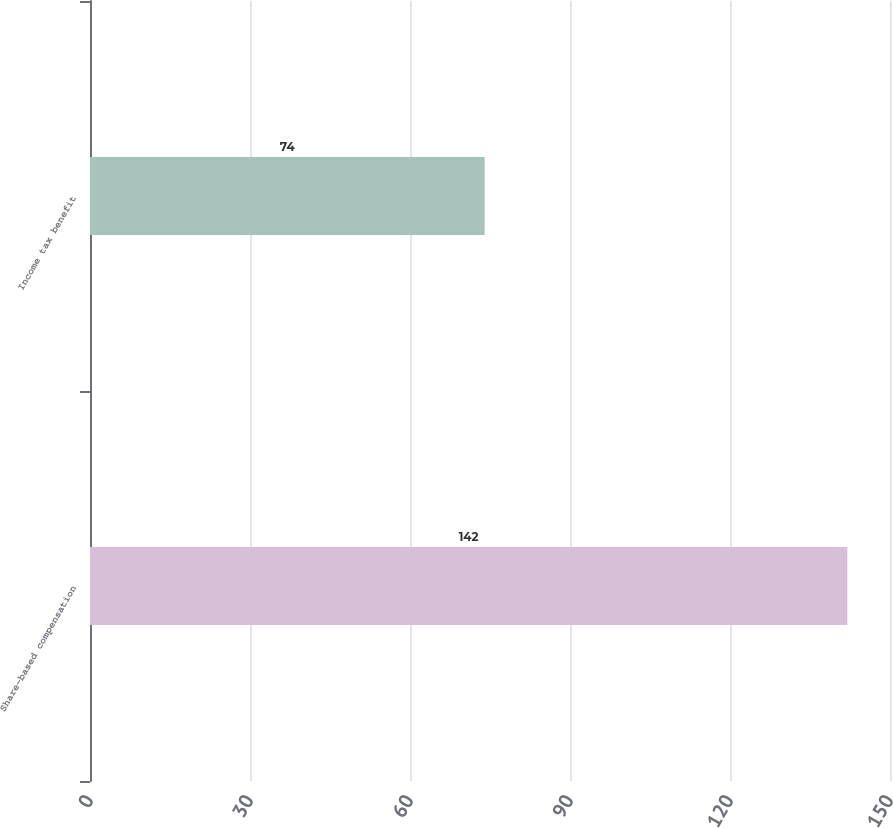Convert chart. <chart><loc_0><loc_0><loc_500><loc_500><bar_chart><fcel>Share-based compensation<fcel>Income tax benefit<nl><fcel>142<fcel>74<nl></chart> 